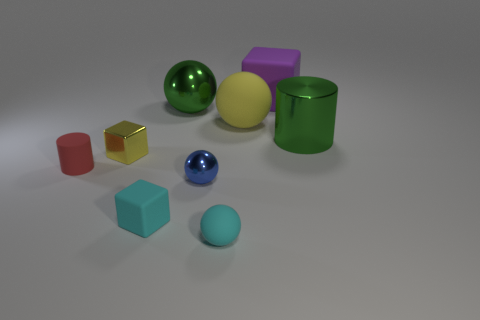Subtract all red cylinders. Subtract all cyan blocks. How many cylinders are left? 1 Subtract all cylinders. How many objects are left? 7 Add 7 big metallic balls. How many big metallic balls exist? 8 Subtract 0 green cubes. How many objects are left? 9 Subtract all big gray metallic cubes. Subtract all large rubber spheres. How many objects are left? 8 Add 9 big rubber blocks. How many big rubber blocks are left? 10 